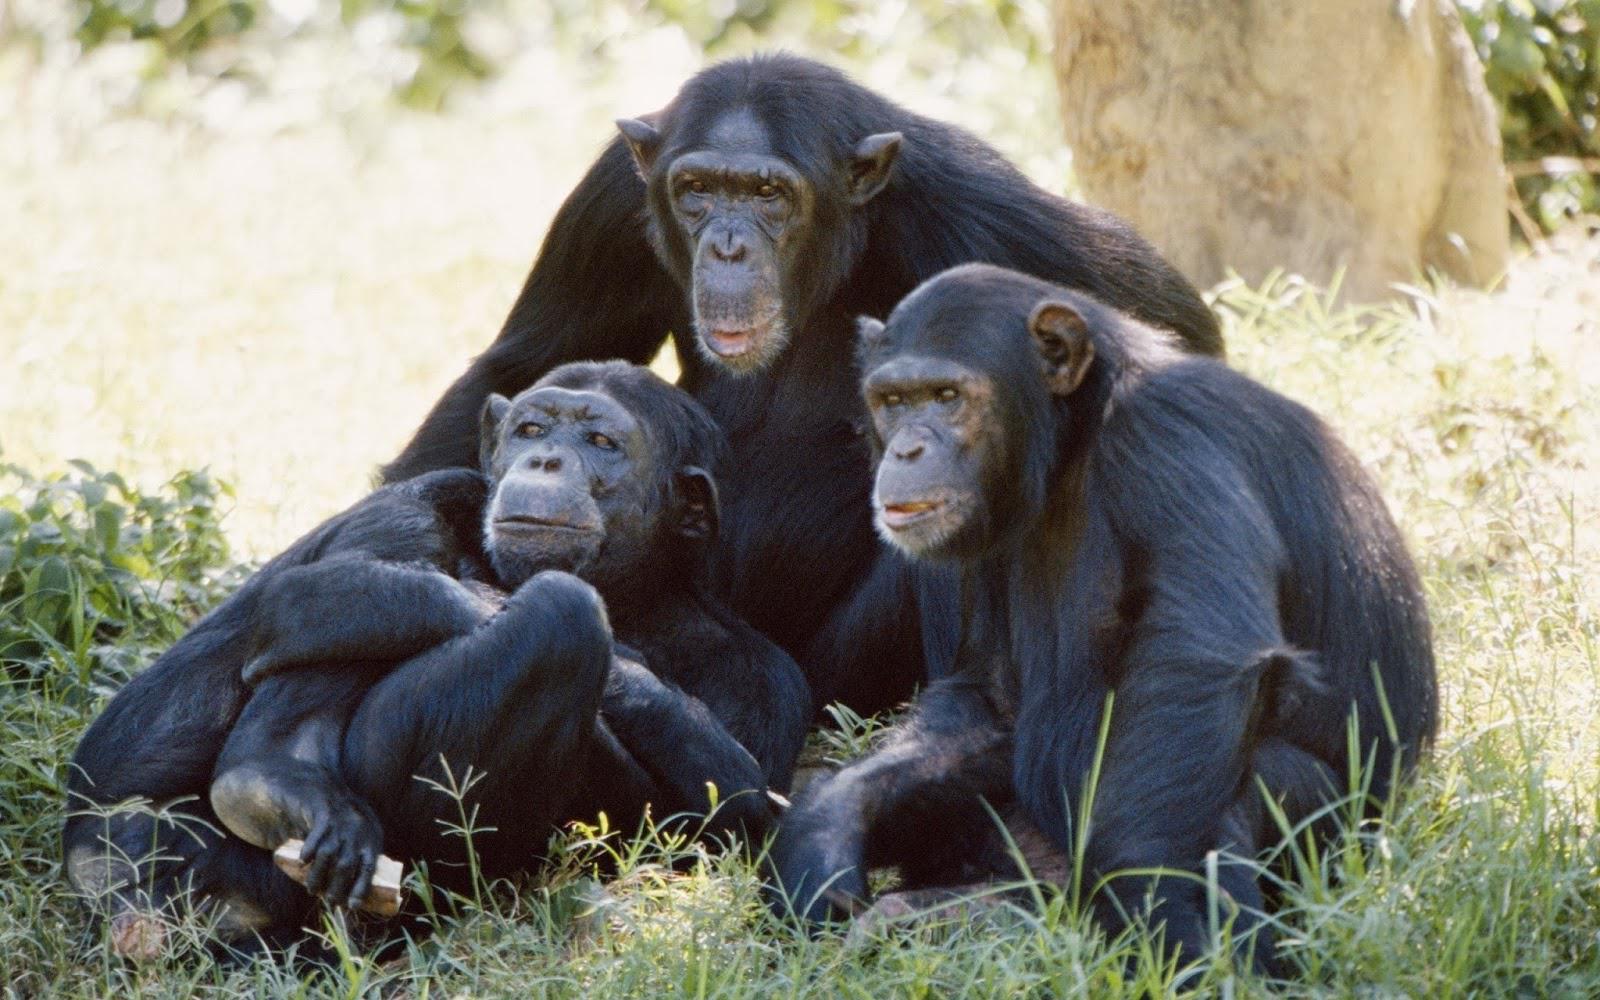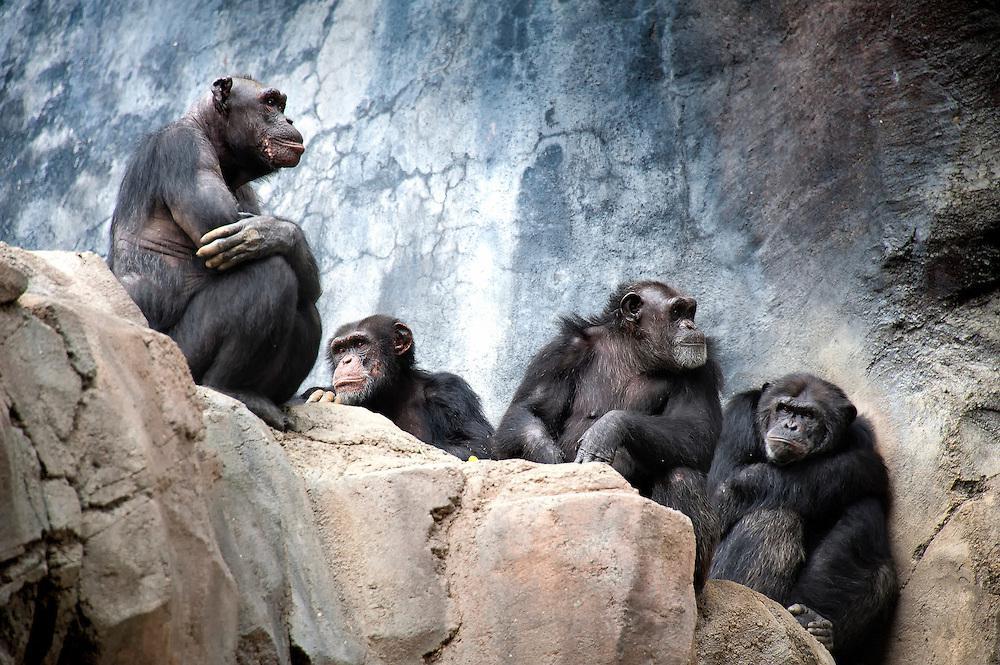The first image is the image on the left, the second image is the image on the right. Analyze the images presented: Is the assertion "Left image contains no more than four chimps, including a close trio." valid? Answer yes or no. Yes. 